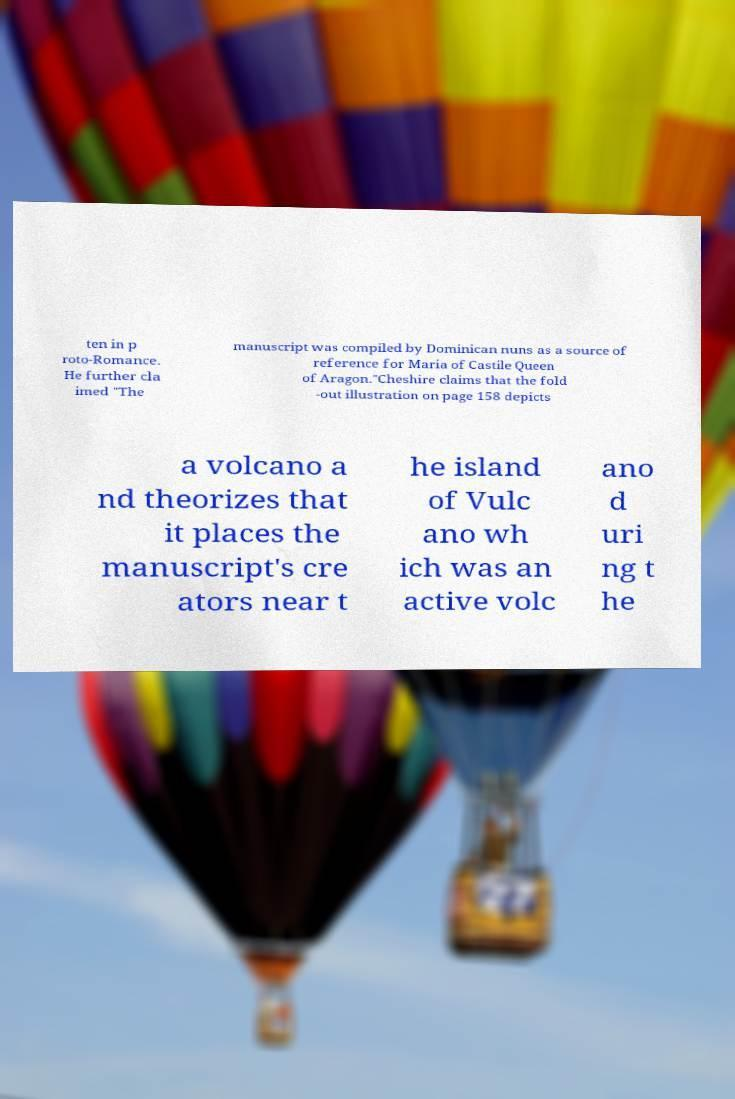Can you accurately transcribe the text from the provided image for me? ten in p roto-Romance. He further cla imed "The manuscript was compiled by Dominican nuns as a source of reference for Maria of Castile Queen of Aragon."Cheshire claims that the fold -out illustration on page 158 depicts a volcano a nd theorizes that it places the manuscript's cre ators near t he island of Vulc ano wh ich was an active volc ano d uri ng t he 